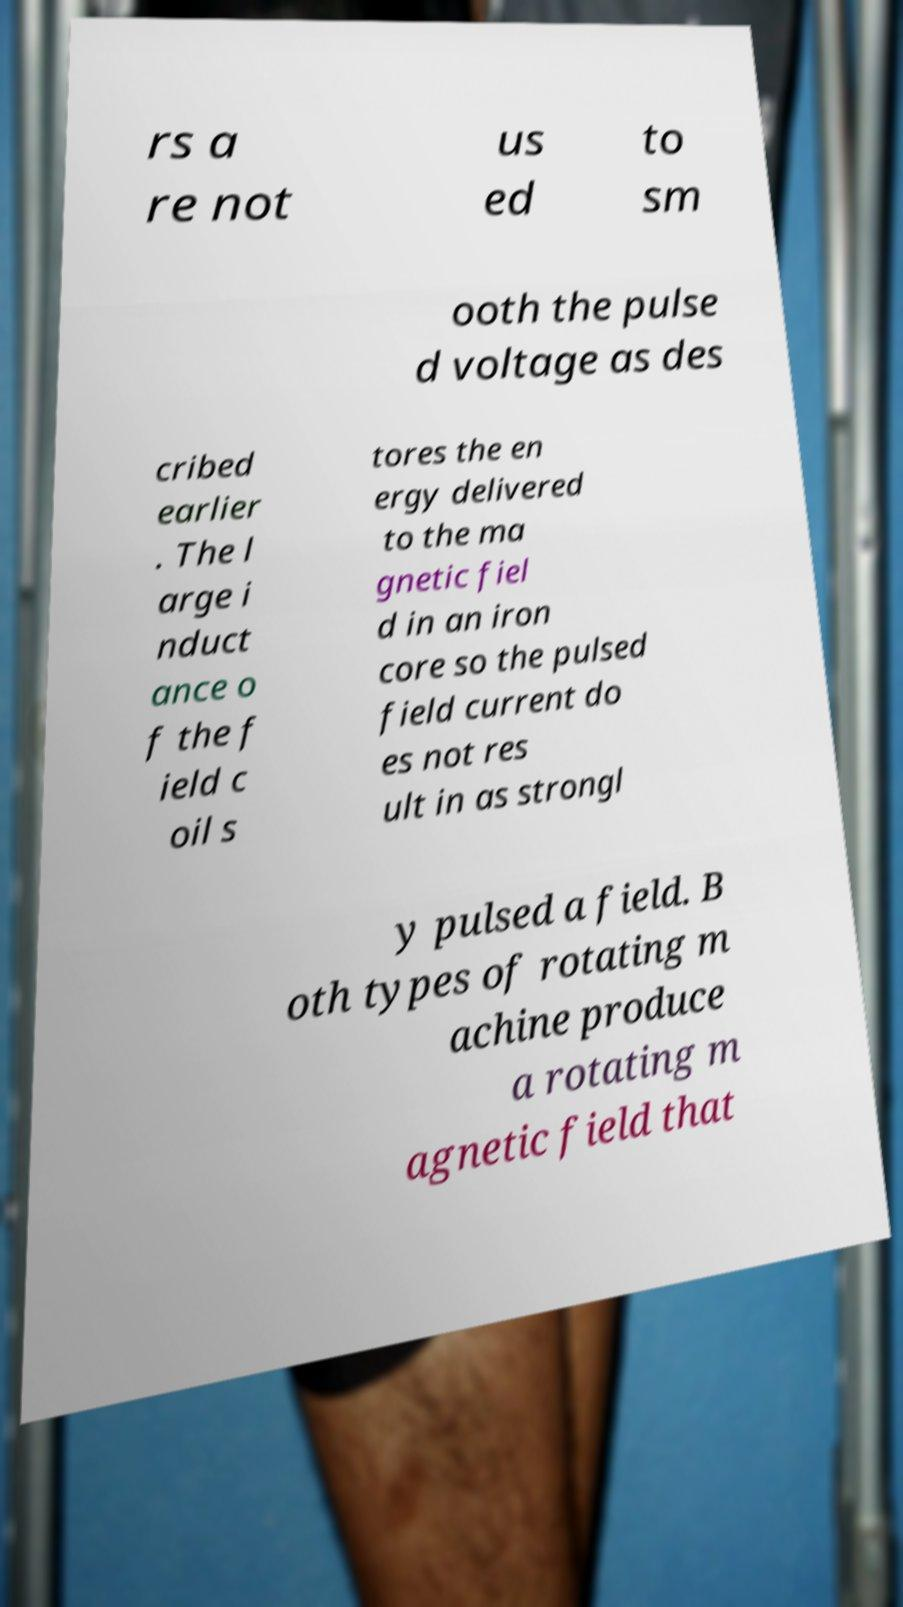Please read and relay the text visible in this image. What does it say? rs a re not us ed to sm ooth the pulse d voltage as des cribed earlier . The l arge i nduct ance o f the f ield c oil s tores the en ergy delivered to the ma gnetic fiel d in an iron core so the pulsed field current do es not res ult in as strongl y pulsed a field. B oth types of rotating m achine produce a rotating m agnetic field that 